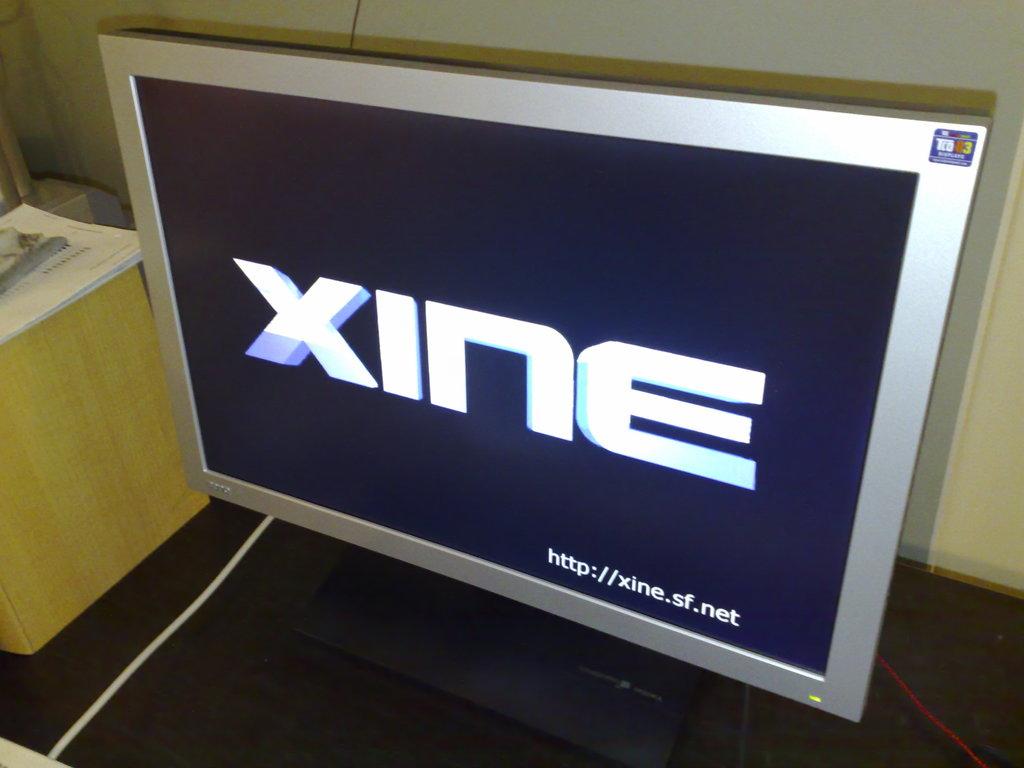What is the website featured on the screen?
Offer a terse response. Xine. What brand is shown on the monitor?
Provide a succinct answer. Xine. 